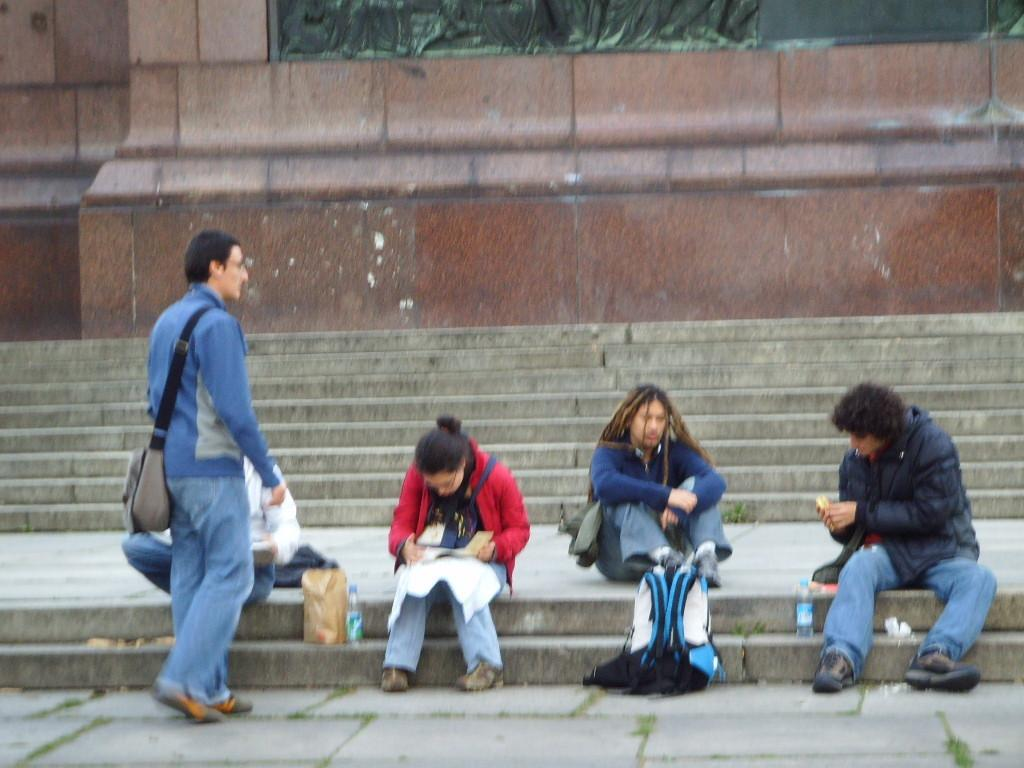What are the persons in the image doing? The persons in the image are sitting and standing on the steps. What can be seen behind the steps? There is a wall behind the steps. What type of leather can be seen on the clam in the image? There is no clam or leather present in the image; it only features persons sitting and standing on the steps with a wall behind them. 